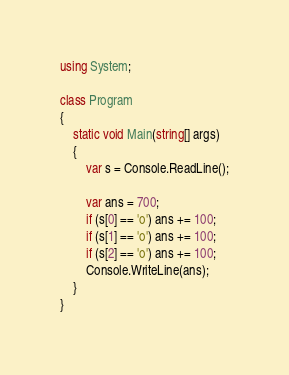<code> <loc_0><loc_0><loc_500><loc_500><_C#_>using System;

class Program
{
    static void Main(string[] args)
    {
        var s = Console.ReadLine();

        var ans = 700;
        if (s[0] == 'o') ans += 100;
        if (s[1] == 'o') ans += 100;
        if (s[2] == 'o') ans += 100;
        Console.WriteLine(ans);
    }
}
</code> 